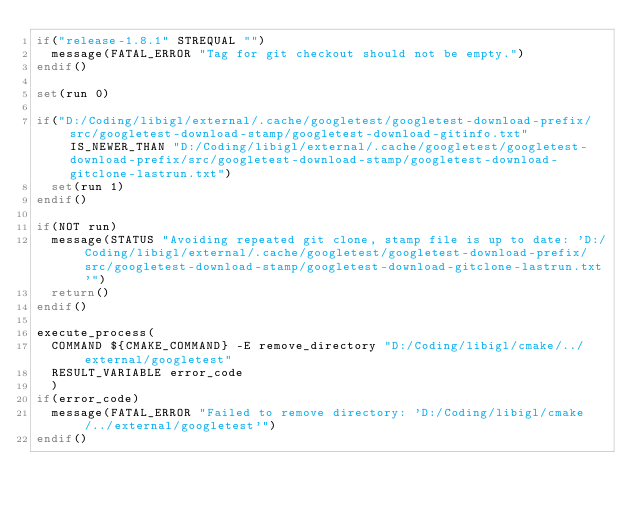Convert code to text. <code><loc_0><loc_0><loc_500><loc_500><_CMake_>if("release-1.8.1" STREQUAL "")
  message(FATAL_ERROR "Tag for git checkout should not be empty.")
endif()

set(run 0)

if("D:/Coding/libigl/external/.cache/googletest/googletest-download-prefix/src/googletest-download-stamp/googletest-download-gitinfo.txt" IS_NEWER_THAN "D:/Coding/libigl/external/.cache/googletest/googletest-download-prefix/src/googletest-download-stamp/googletest-download-gitclone-lastrun.txt")
  set(run 1)
endif()

if(NOT run)
  message(STATUS "Avoiding repeated git clone, stamp file is up to date: 'D:/Coding/libigl/external/.cache/googletest/googletest-download-prefix/src/googletest-download-stamp/googletest-download-gitclone-lastrun.txt'")
  return()
endif()

execute_process(
  COMMAND ${CMAKE_COMMAND} -E remove_directory "D:/Coding/libigl/cmake/../external/googletest"
  RESULT_VARIABLE error_code
  )
if(error_code)
  message(FATAL_ERROR "Failed to remove directory: 'D:/Coding/libigl/cmake/../external/googletest'")
endif()
</code> 